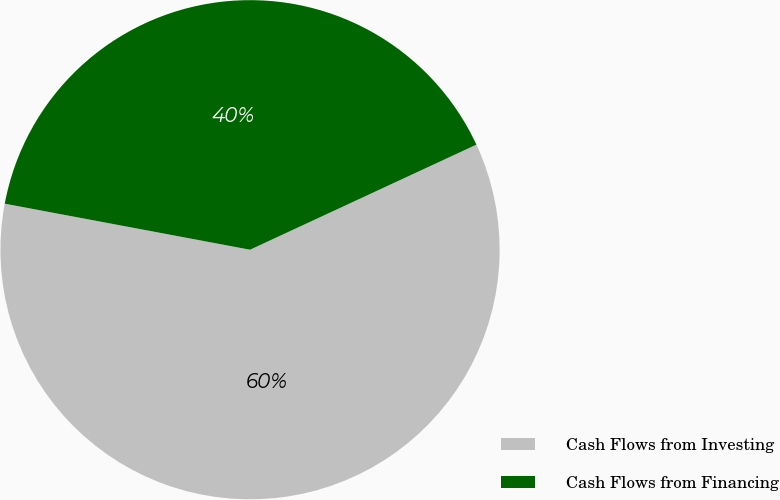<chart> <loc_0><loc_0><loc_500><loc_500><pie_chart><fcel>Cash Flows from Investing<fcel>Cash Flows from Financing<nl><fcel>59.87%<fcel>40.13%<nl></chart> 